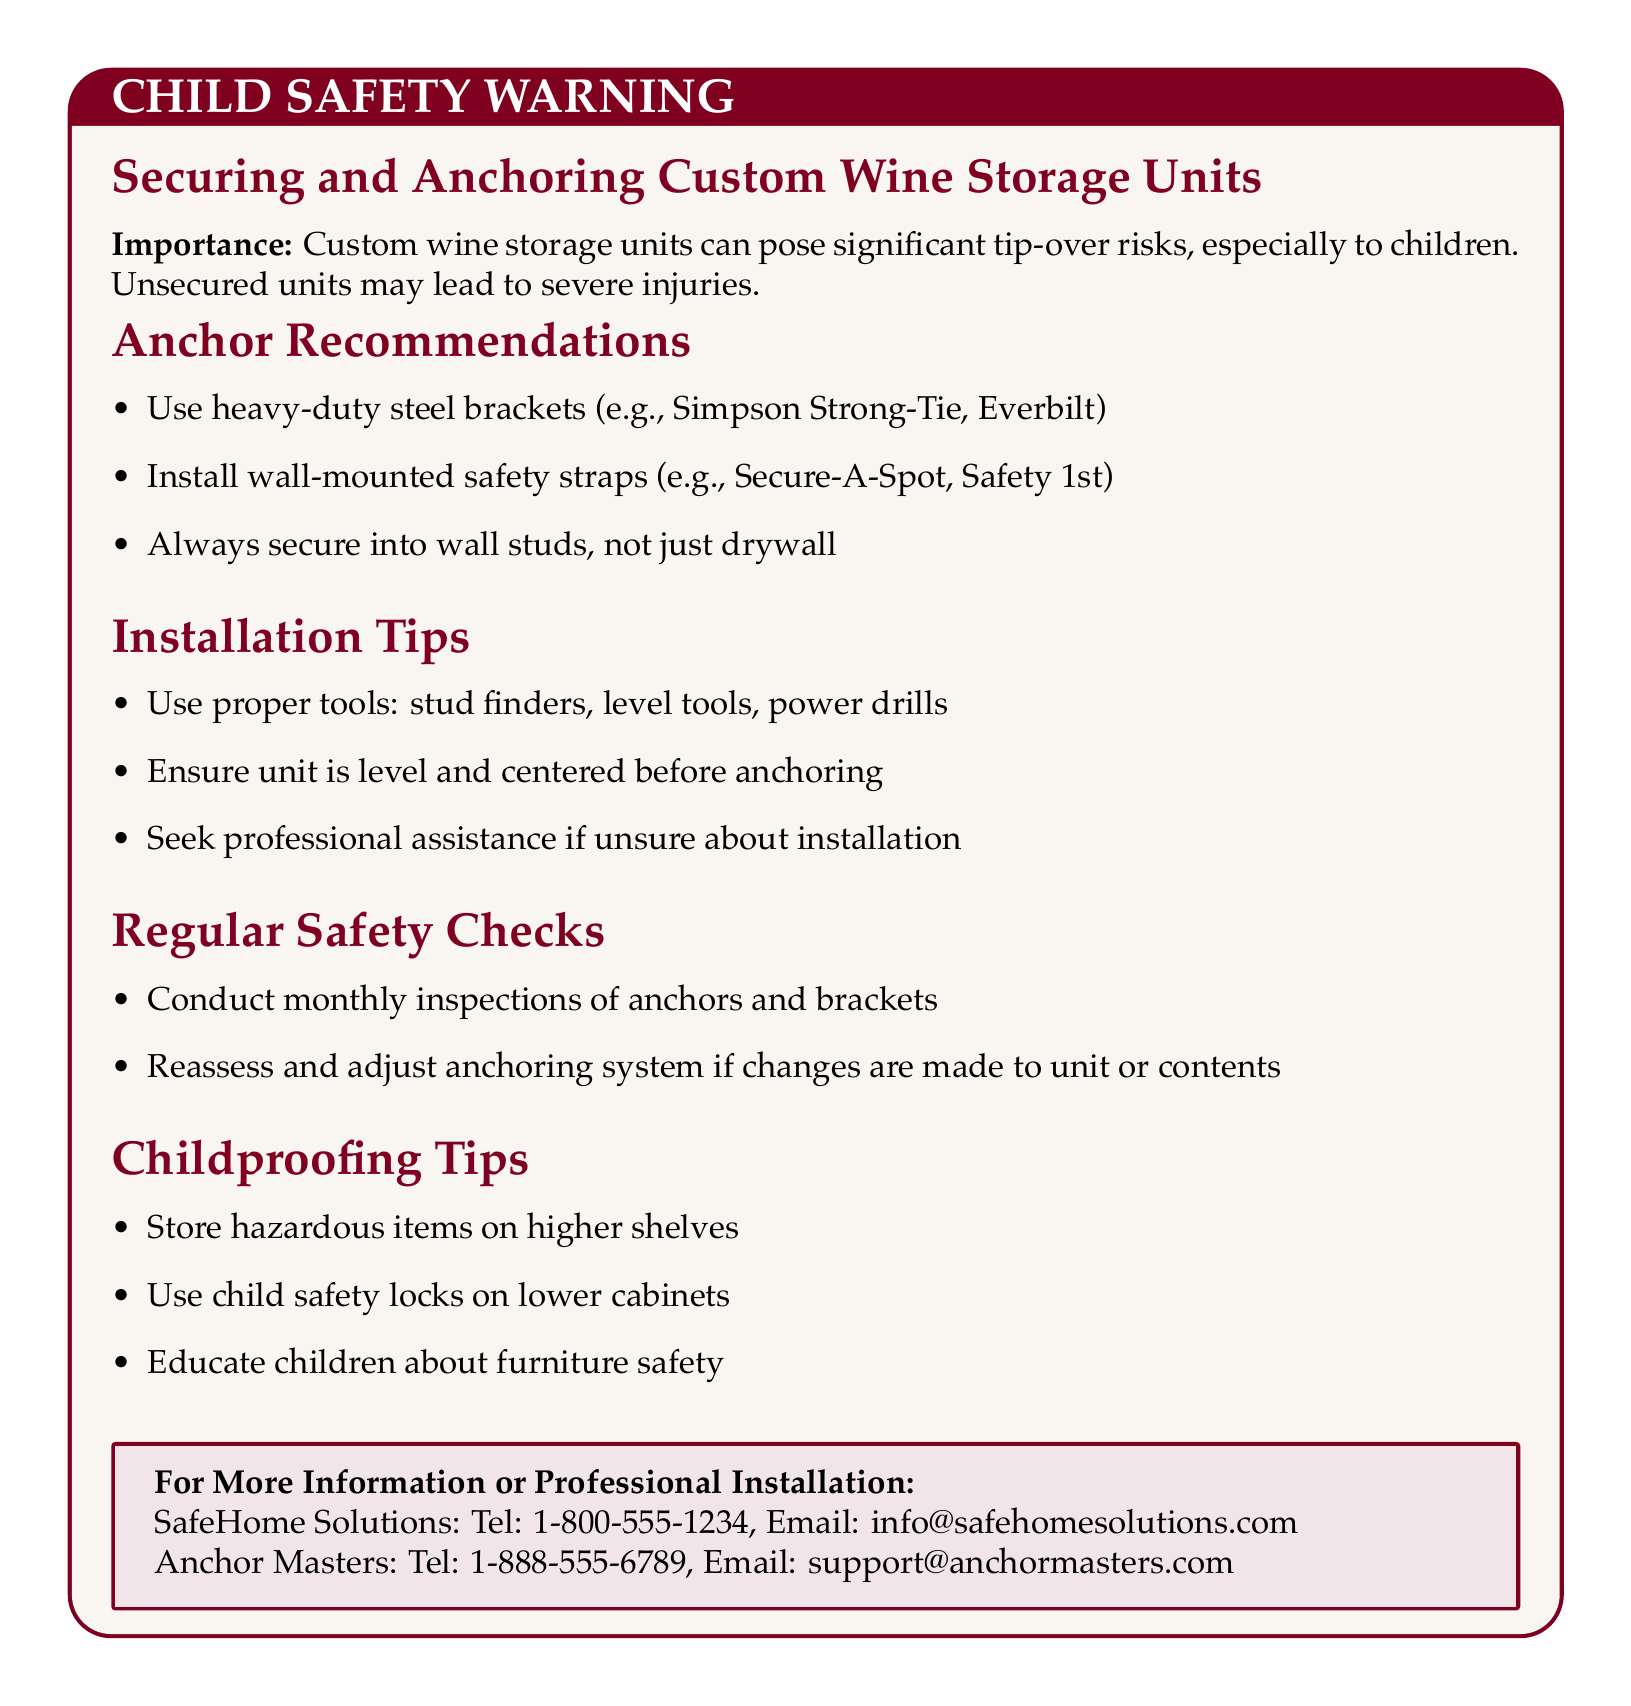What is the title of the warning? The title of the warning is explicitly stated in the document as "CHILD SAFETY WARNING".
Answer: CHILD SAFETY WARNING What are the recommended types of anchors? The document lists specific types of anchors under "Anchor Recommendations", including heavy-duty steel brackets and wall-mounted safety straps.
Answer: heavy-duty steel brackets, wall-mounted safety straps Which tool is advised for finding wall studs? The document mentions using stud finders as a tool for installation tips.
Answer: stud finders How often should regular safety checks be conducted? The section on "Regular Safety Checks" specifies that inspections should be conducted monthly.
Answer: monthly What should hazardous items be stored? The document advises to store hazardous items on higher shelves as part of the childproofing tips.
Answer: higher shelves What should you secure into wall studs? The document emphasizes to secure anchors into wall studs, not just drywall, in the anchor recommendations.
Answer: wall studs What is the contact number for SafeHome Solutions? The document provides the contact number for SafeHome Solutions as part of the information box at the end.
Answer: 1-800-555-1234 What is the first childproofing tip mentioned? The document lists storing hazardous items on higher shelves as the first childproofing tip mentioned in the document.
Answer: Store hazardous items on higher shelves What is suggested if you're unsure about installation? The document suggests seeking professional assistance if unsure about installation under the installation tips.
Answer: Seek professional assistance 